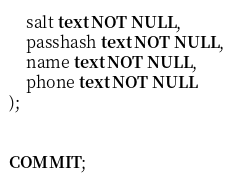Convert code to text. <code><loc_0><loc_0><loc_500><loc_500><_SQL_>	salt text NOT NULL,
	passhash text NOT NULL,
	name text NOT NULL,
	phone text NOT NULL
);


COMMIT;
</code> 